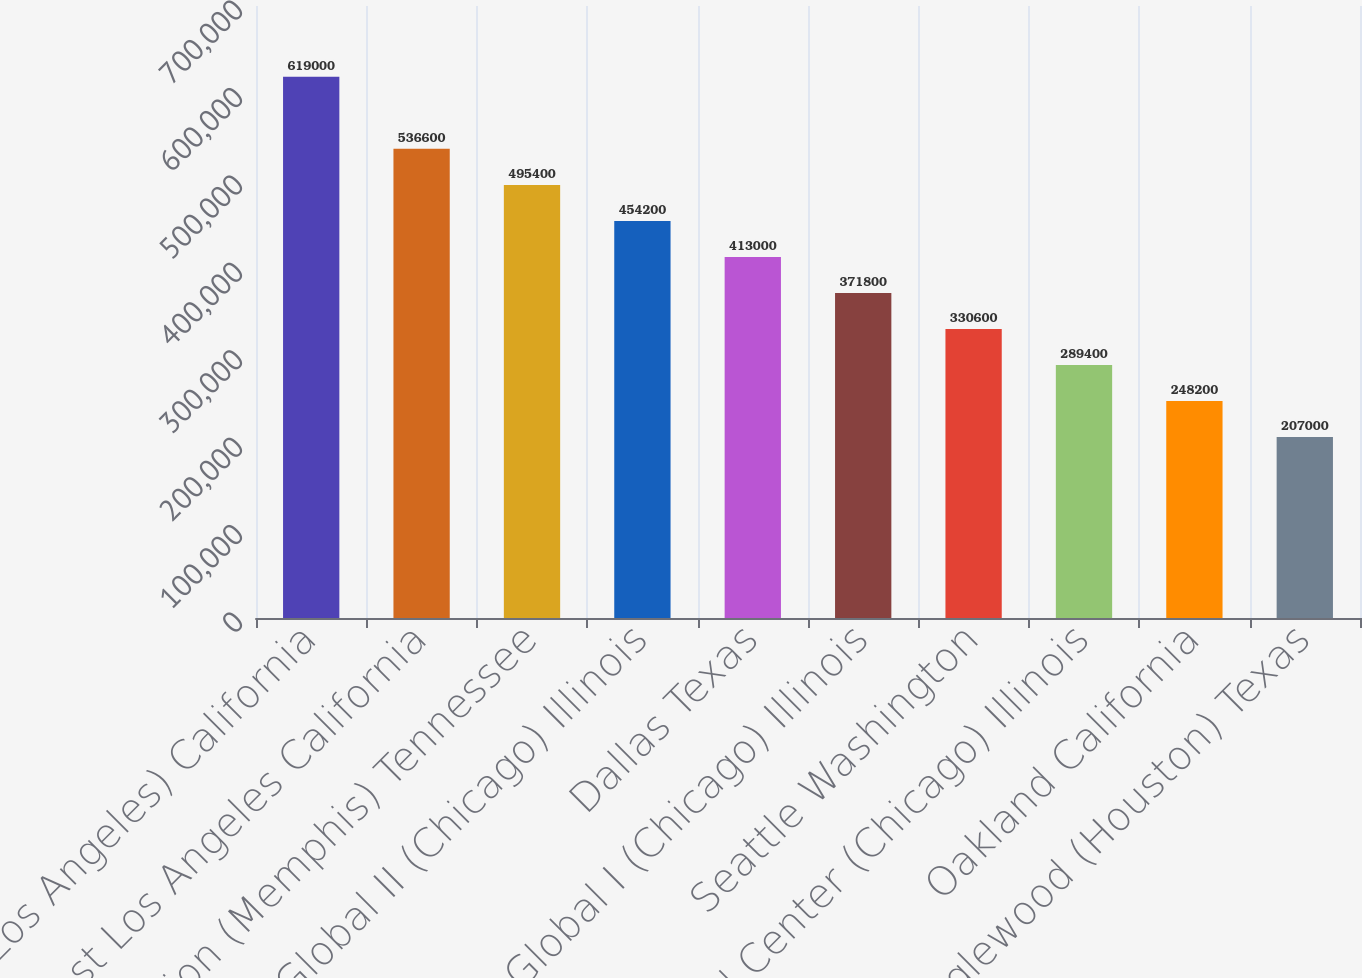Convert chart to OTSL. <chart><loc_0><loc_0><loc_500><loc_500><bar_chart><fcel>ICTF (Los Angeles) California<fcel>East Los Angeles California<fcel>Marion (Memphis) Tennessee<fcel>Global II (Chicago) Illinois<fcel>Dallas Texas<fcel>Global I (Chicago) Illinois<fcel>Seattle Washington<fcel>Yard Center (Chicago) Illinois<fcel>Oakland California<fcel>Englewood (Houston) Texas<nl><fcel>619000<fcel>536600<fcel>495400<fcel>454200<fcel>413000<fcel>371800<fcel>330600<fcel>289400<fcel>248200<fcel>207000<nl></chart> 